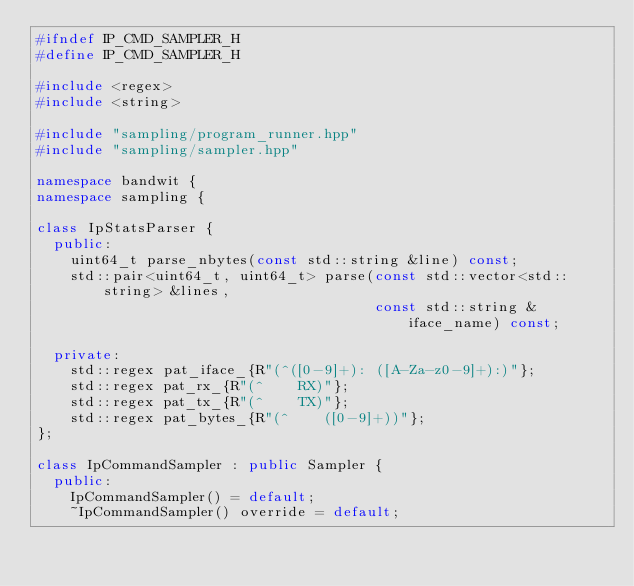<code> <loc_0><loc_0><loc_500><loc_500><_C++_>#ifndef IP_CMD_SAMPLER_H
#define IP_CMD_SAMPLER_H

#include <regex>
#include <string>

#include "sampling/program_runner.hpp"
#include "sampling/sampler.hpp"

namespace bandwit {
namespace sampling {

class IpStatsParser {
  public:
    uint64_t parse_nbytes(const std::string &line) const;
    std::pair<uint64_t, uint64_t> parse(const std::vector<std::string> &lines,
                                        const std::string &iface_name) const;

  private:
    std::regex pat_iface_{R"(^([0-9]+): ([A-Za-z0-9]+):)"};
    std::regex pat_rx_{R"(^    RX)"};
    std::regex pat_tx_{R"(^    TX)"};
    std::regex pat_bytes_{R"(^    ([0-9]+))"};
};

class IpCommandSampler : public Sampler {
  public:
    IpCommandSampler() = default;
    ~IpCommandSampler() override = default;
</code> 